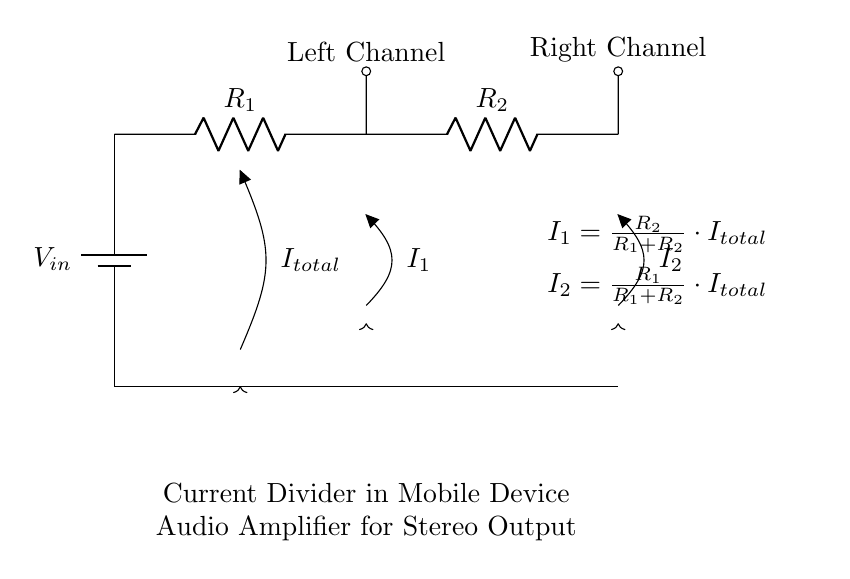what type of circuit is this? This is a current divider circuit. It shows how an input current splits into two branches, each passing through a resistor. The arrangement is designed specifically to create balanced outputs for stereo audio.
Answer: current divider what are the values of the resistors in the circuit? The resistor values are labeled as R1 and R2. The specific numerical values for these resistors are not provided in the diagram; they are generic components in the current divider setup.
Answer: R1 and R2 what is the total current in this circuit? The total current is denoted as I total, which indicates the incoming current from the voltage source before it divides into the branches with resistors.
Answer: I total how can you calculate the current through R1? The current through R1 can be calculated using the equation I1 equals R2 divided by the sum of R1 and R2, multiplied by I total. This incorporates both resistances into the calculation.
Answer: I1 = (R2 / (R1 + R2)) * I total how does the value of R1 affect I1? Increasing R1 while keeping R2 constant would decrease I1, as a larger resistance in the current divider formula leads to a smaller fraction of the total current passing through it. Thus, R1 inversely influences I1.
Answer: Inversely what currents are present in the system? The currents present include I total, representing the incoming current, I1 through R1, and I2 through R2, showcasing how the total current splits.
Answer: I total, I1, I2 what is the purpose of the short outputs in the diagram? The short outputs represent the left and right audio channels, indicating where the separated currents are directed for stereo output in the audio amplifier circuit.
Answer: Stereo output 